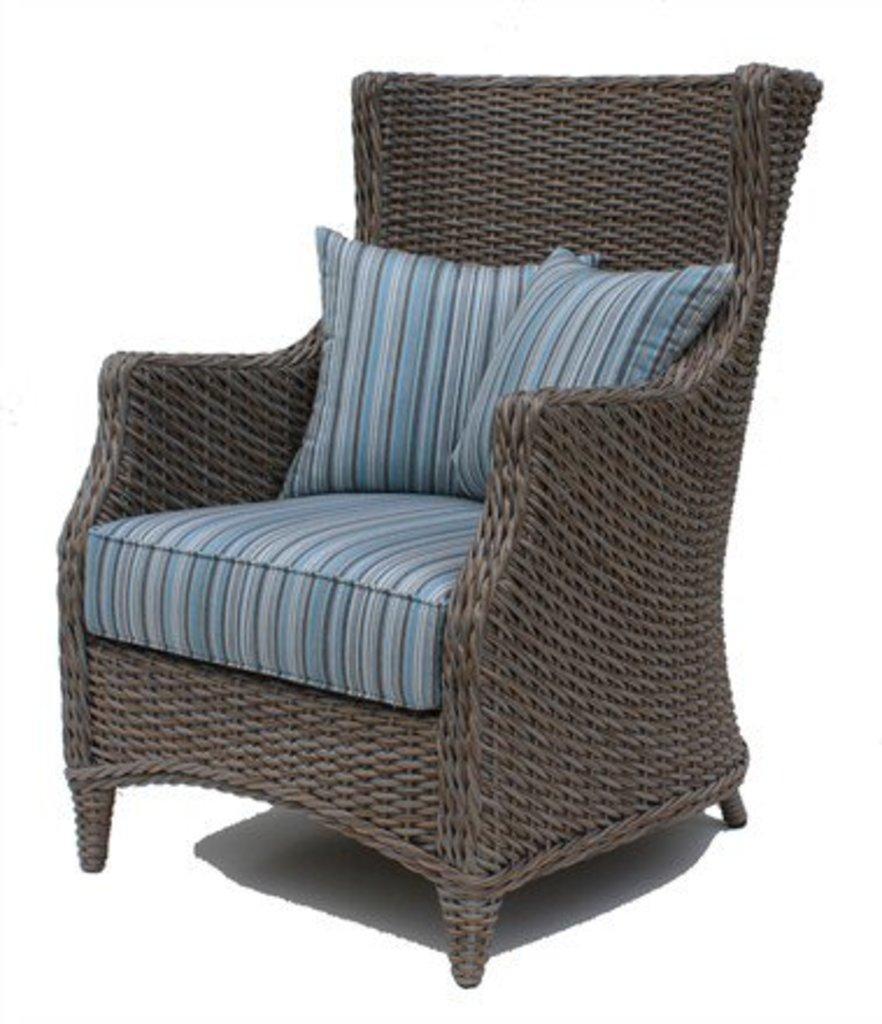In one or two sentences, can you explain what this image depicts? In the center of the image we can see a chair and there are cushions placed on it. 